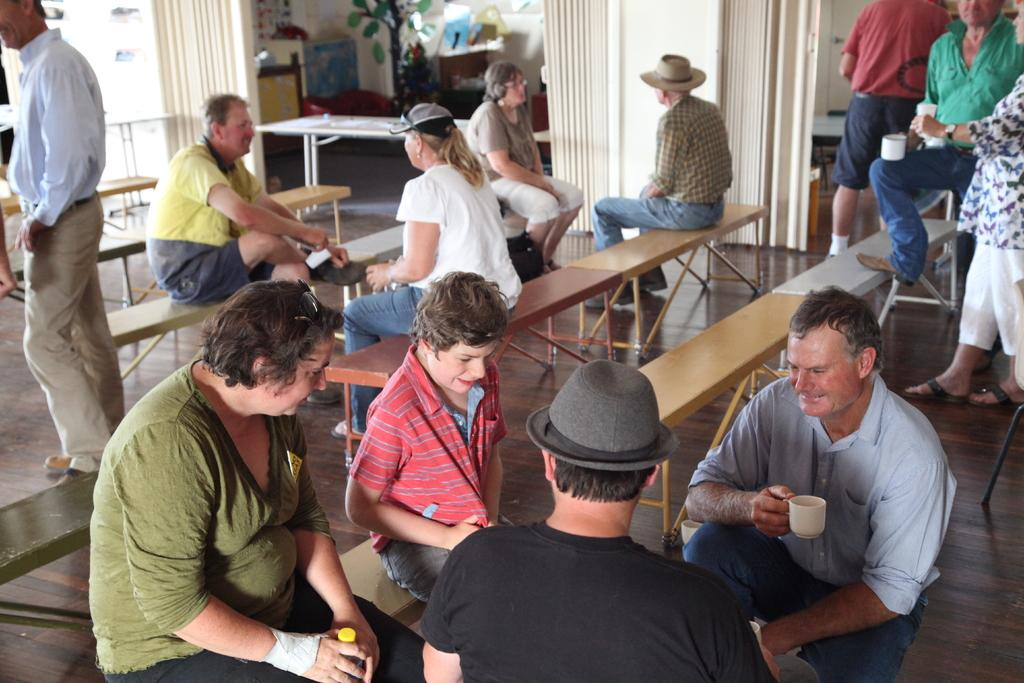How many people are in the image? There is a group of persons in the image. What are the people in the image doing? Some of the persons are sitting, while others are standing. What can be seen in the background of the image? There is a wall and a plant in the background of the image. What is the color of the table in the image? The table in the image is white in color. What type of amusement can be seen on the marble table in the image? There is no marble table or amusement present in the image. 